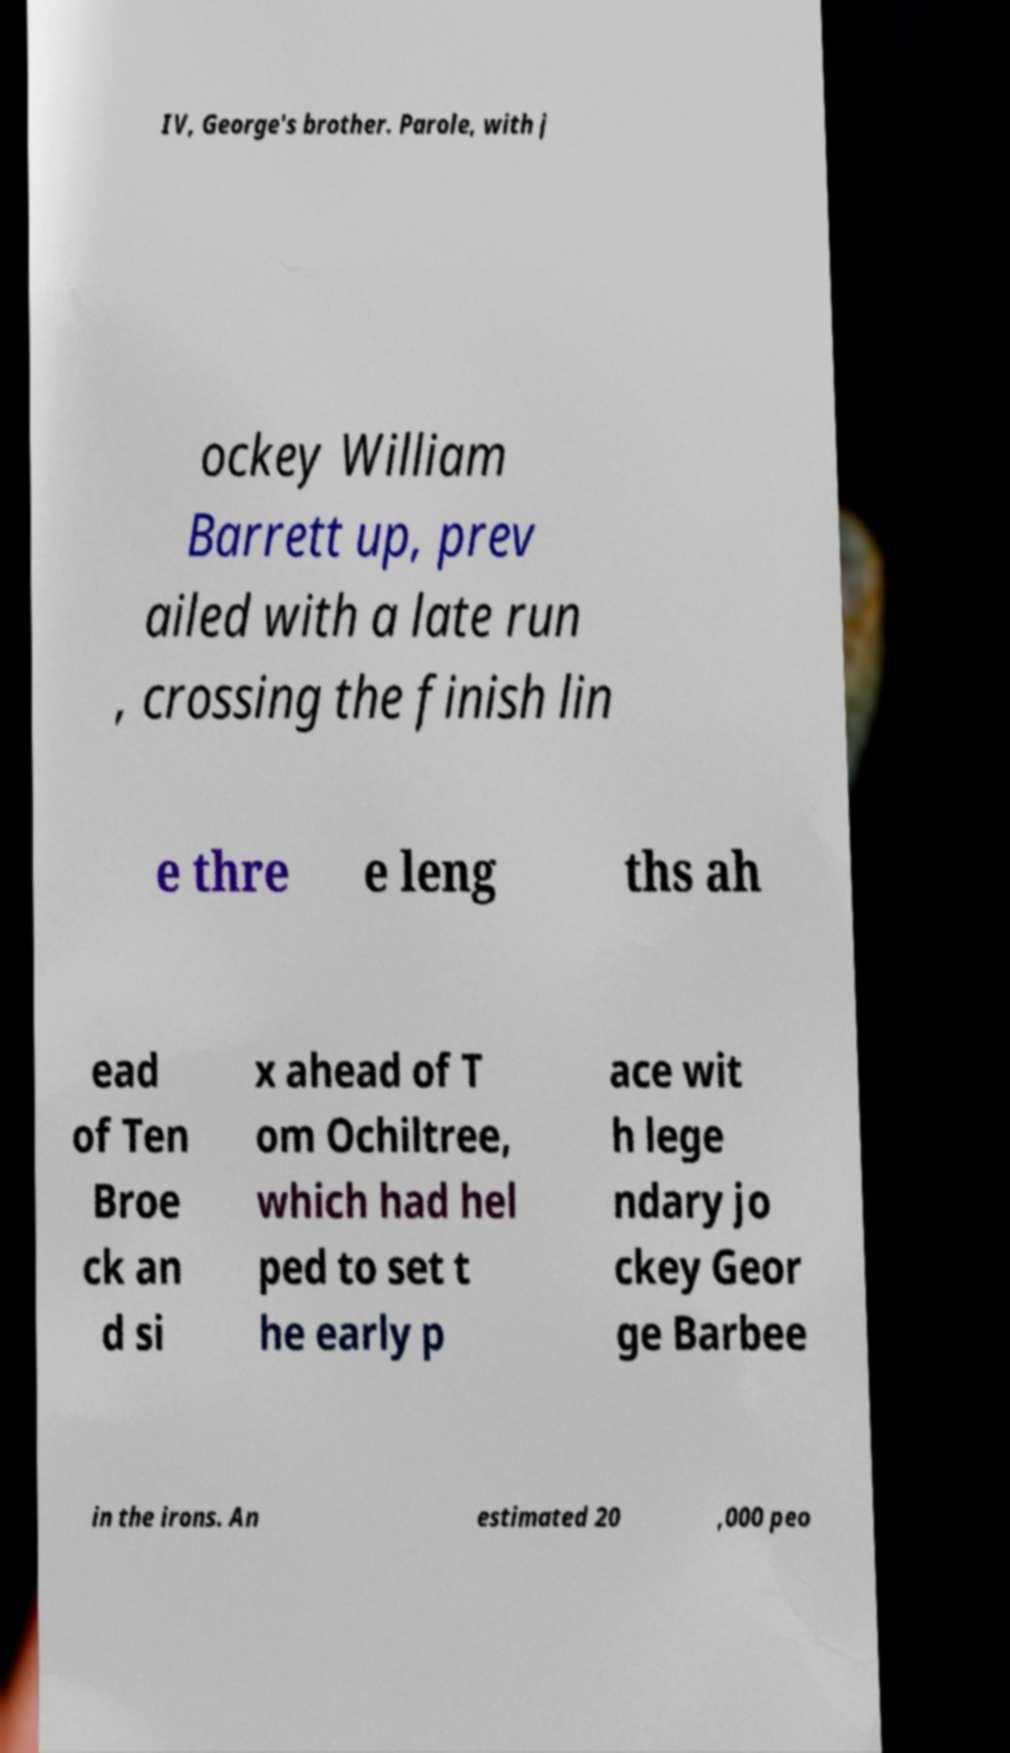I need the written content from this picture converted into text. Can you do that? IV, George's brother. Parole, with j ockey William Barrett up, prev ailed with a late run , crossing the finish lin e thre e leng ths ah ead of Ten Broe ck an d si x ahead of T om Ochiltree, which had hel ped to set t he early p ace wit h lege ndary jo ckey Geor ge Barbee in the irons. An estimated 20 ,000 peo 